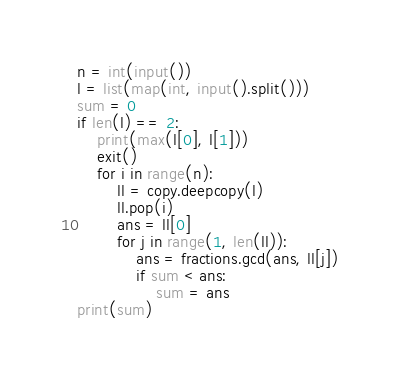<code> <loc_0><loc_0><loc_500><loc_500><_Python_>n = int(input())
l = list(map(int, input().split()))
sum = 0
if len(l) == 2:
    print(max(l[0], l[1]))
    exit()
    for i in range(n):
        ll = copy.deepcopy(l)
        ll.pop(i)
        ans = ll[0]
        for j in range(1, len(ll)):
            ans = fractions.gcd(ans, ll[j])
            if sum < ans:
                sum = ans
print(sum)</code> 